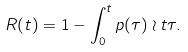<formula> <loc_0><loc_0><loc_500><loc_500>R ( t ) = 1 - \int _ { 0 } ^ { t } p ( \tau ) \wr t \tau .</formula> 